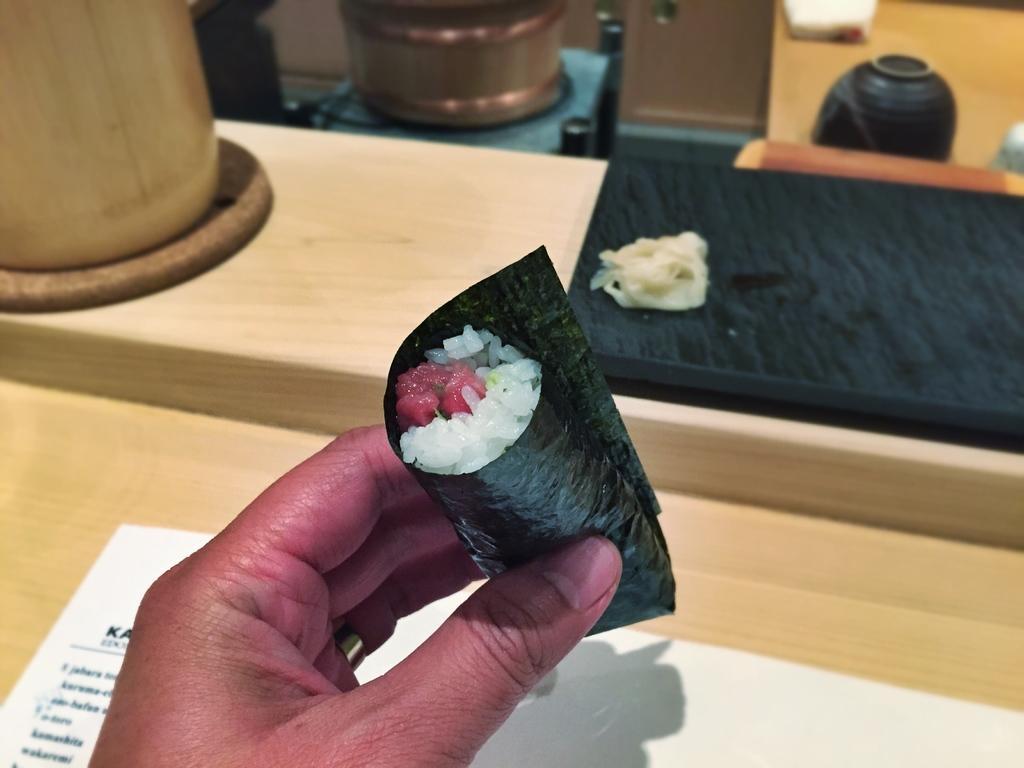In one or two sentences, can you explain what this image depicts? In this image there is a person's hand truncated towards the bottom of the image, there is an object in the person's hand, there is a table truncated, there is a paper truncated towards the bottom of the image, there are objects on the table, there is an object truncated towards the left of the image, there are objects truncated towards the right of the image, there are objects truncated towards the top of the image. 